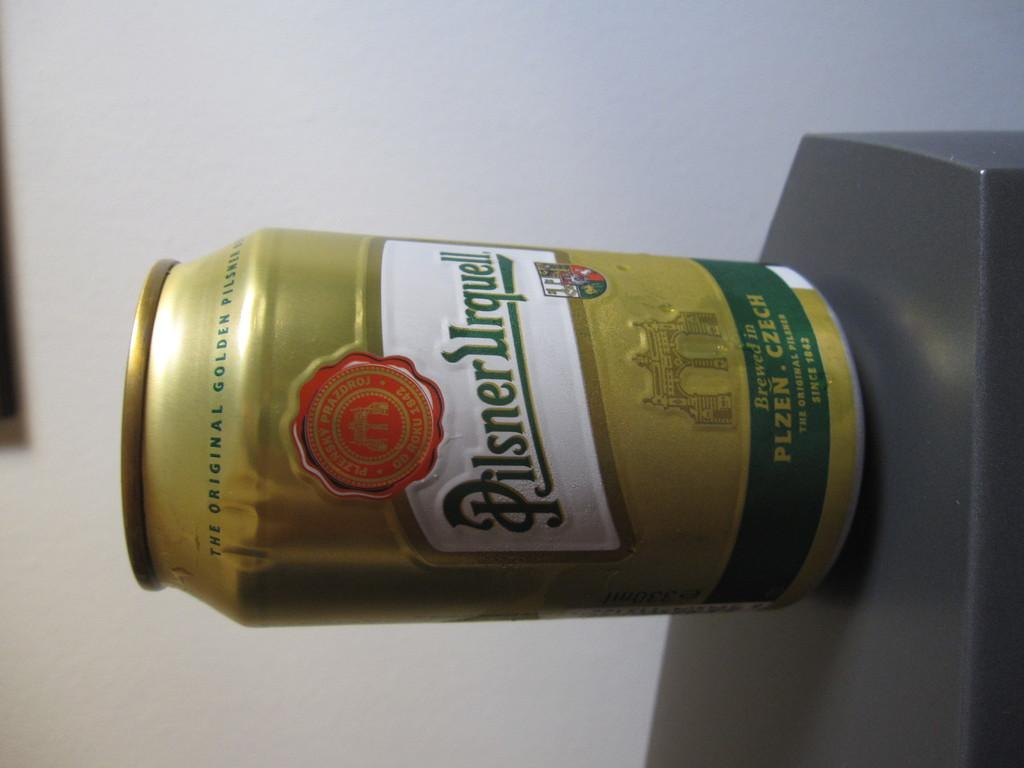Provide a one-sentence caption for the provided image. A can of Pilsner Urquell sits on a dark surface. 